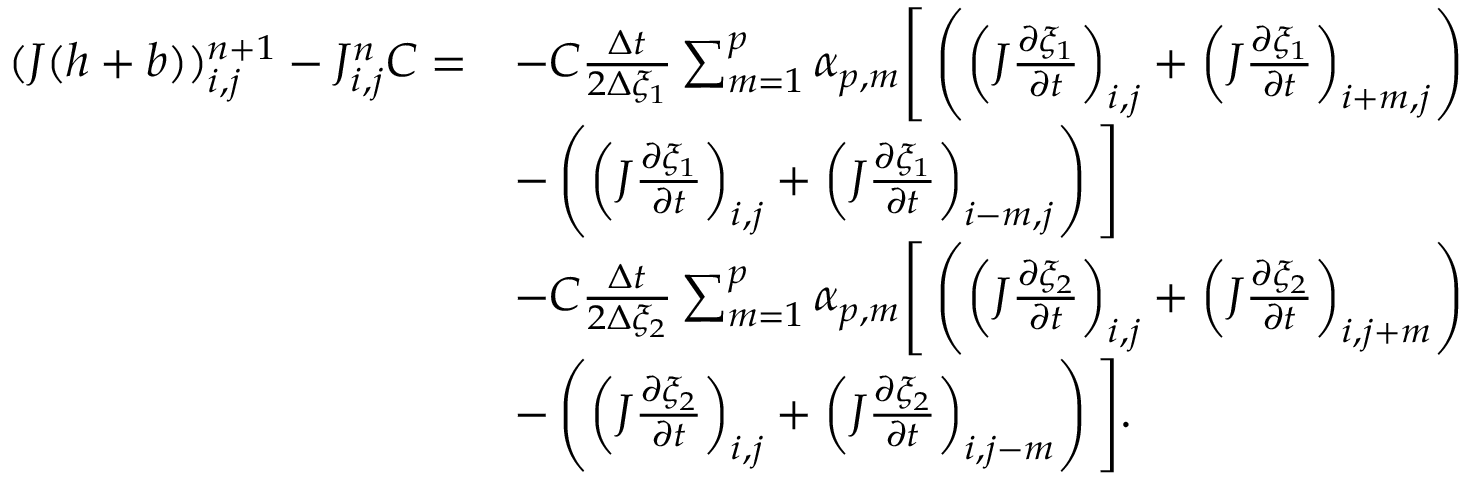<formula> <loc_0><loc_0><loc_500><loc_500>\begin{array} { r l } { ( J ( h + b ) ) _ { i , j } ^ { n + 1 } - J _ { i , j } ^ { n } C = } & { - C \frac { \Delta t } { 2 \Delta { \xi _ { 1 } } } \sum _ { m = 1 } ^ { p } \alpha _ { p , m } \left [ \left ( \left ( J \frac { \partial \xi _ { 1 } } { \partial t } \right ) _ { i , j } + \left ( J \frac { \partial \xi _ { 1 } } { \partial t } \right ) _ { i + m , j } \right ) } \\ & { - \left ( \left ( J \frac { \partial \xi _ { 1 } } { \partial t } \right ) _ { i , j } + \left ( J \frac { \partial \xi _ { 1 } } { \partial t } \right ) _ { i - m , j } \right ) \right ] } \\ & { - C \frac { \Delta t } { 2 \Delta { \xi _ { 2 } } } \sum _ { m = 1 } ^ { p } \alpha _ { p , m } \left [ \left ( \left ( J \frac { \partial \xi _ { 2 } } { \partial t } \right ) _ { i , j } + \left ( J \frac { \partial \xi _ { 2 } } { \partial t } \right ) _ { i , j + m } \right ) } \\ & { - \left ( \left ( J \frac { \partial \xi _ { 2 } } { \partial t } \right ) _ { i , j } + \left ( J \frac { \partial \xi _ { 2 } } { \partial t } \right ) _ { i , j - m } \right ) \right ] . } \end{array}</formula> 